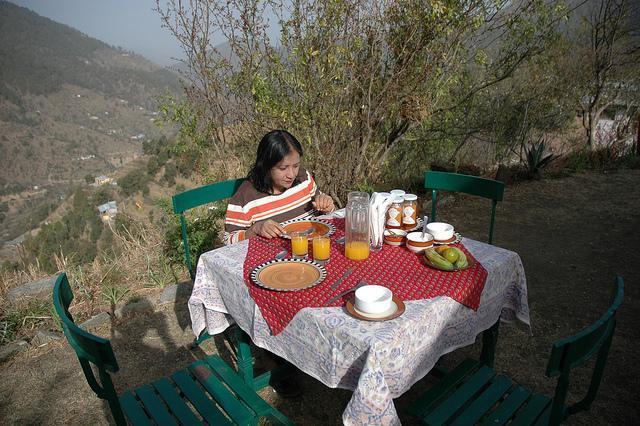How many chairs are visible?
Give a very brief answer. 3. How many dining tables are visible?
Give a very brief answer. 1. 